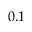Convert formula to latex. <formula><loc_0><loc_0><loc_500><loc_500>0 . 1</formula> 